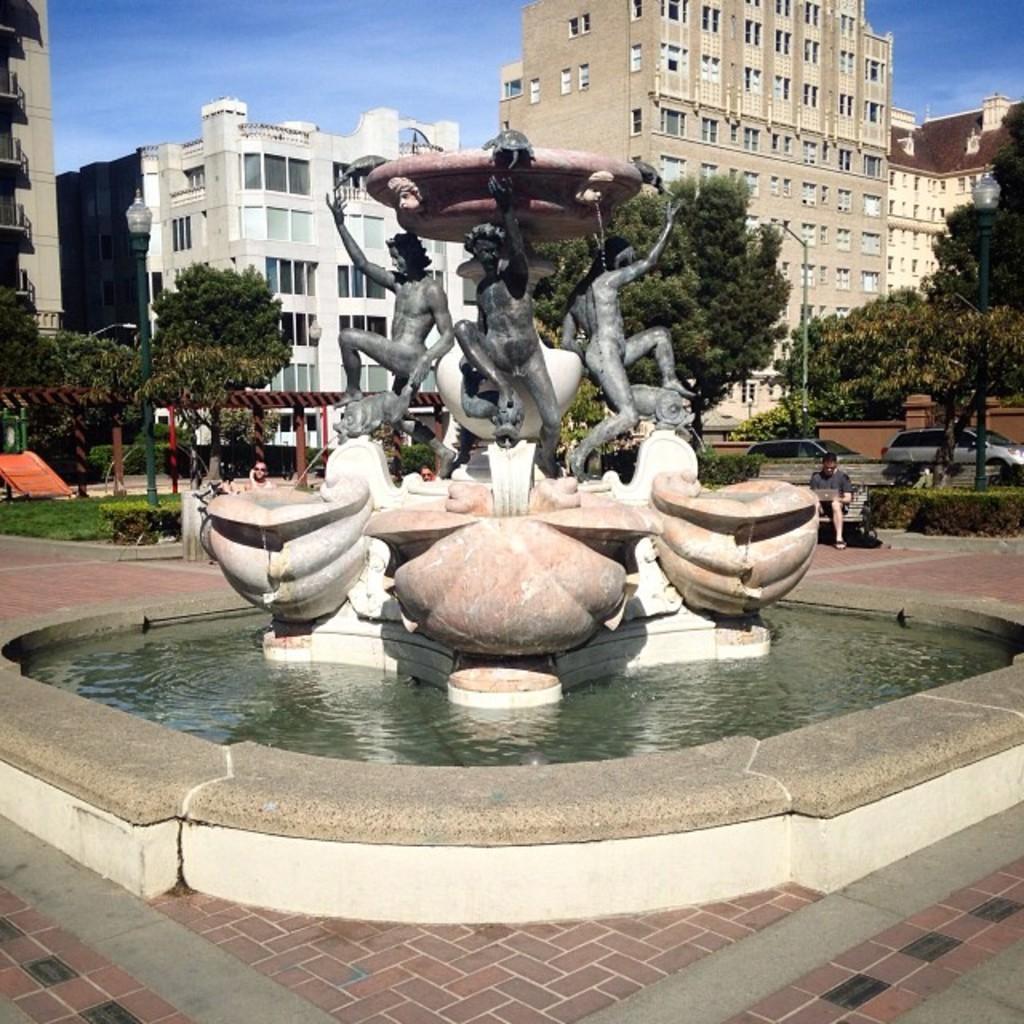In one or two sentences, can you explain what this image depicts? In this image I can see the water fountain, statues on the fountain and people. Among these people some are standing and some are sitting. In the background I can see buildings, trees, street lights and the sky. Here I can see the grass. 